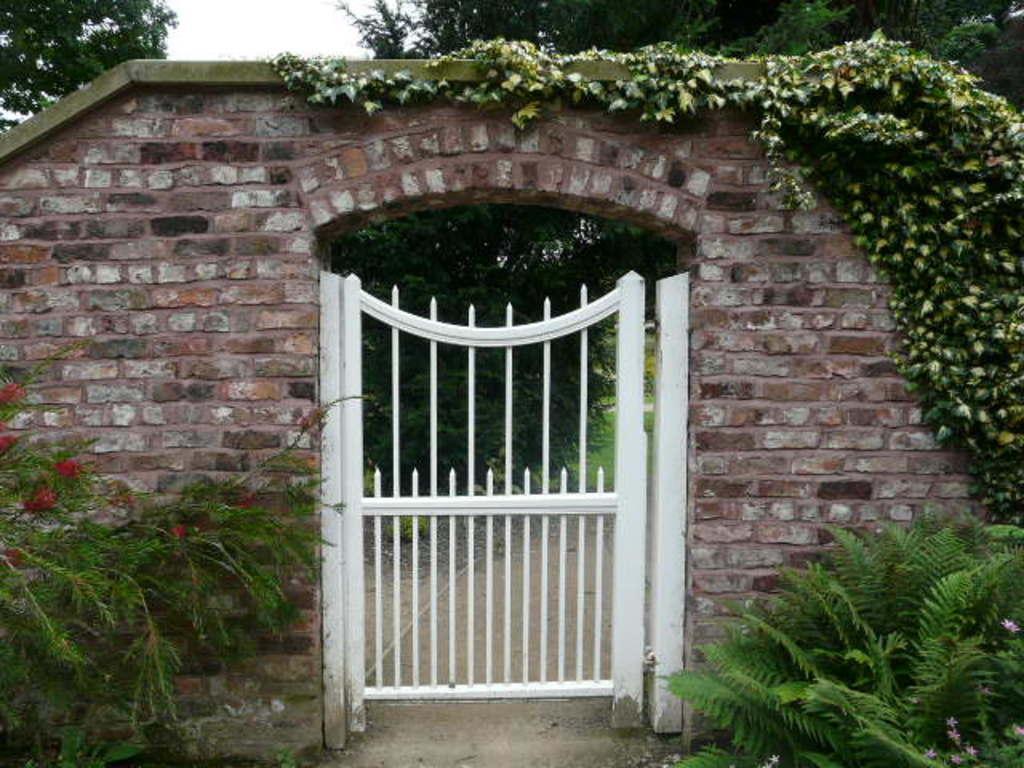Can you describe this image briefly? In this picture there is a white color gate in the image and there is an arch above the gate and there is greenery around the image. 